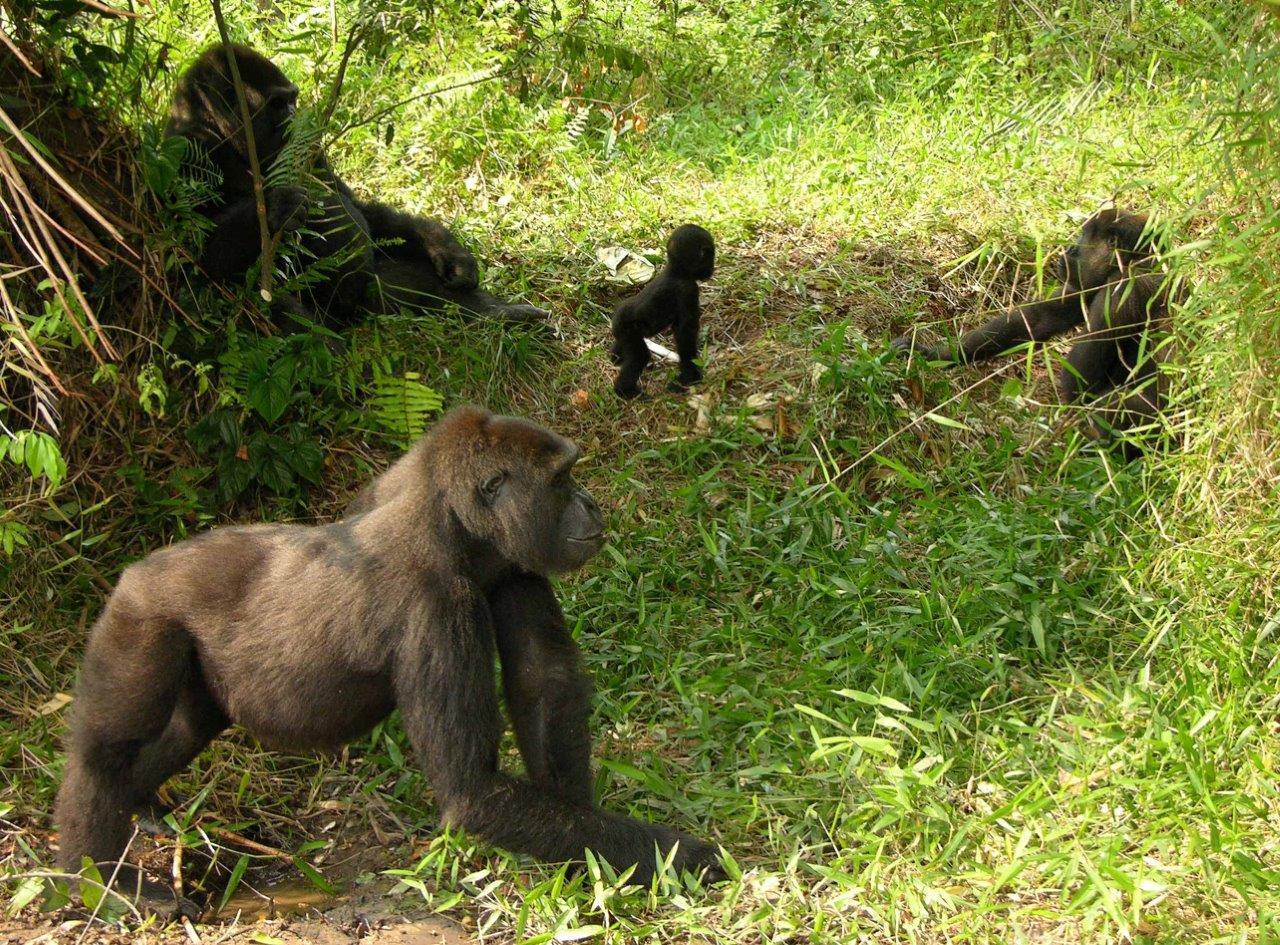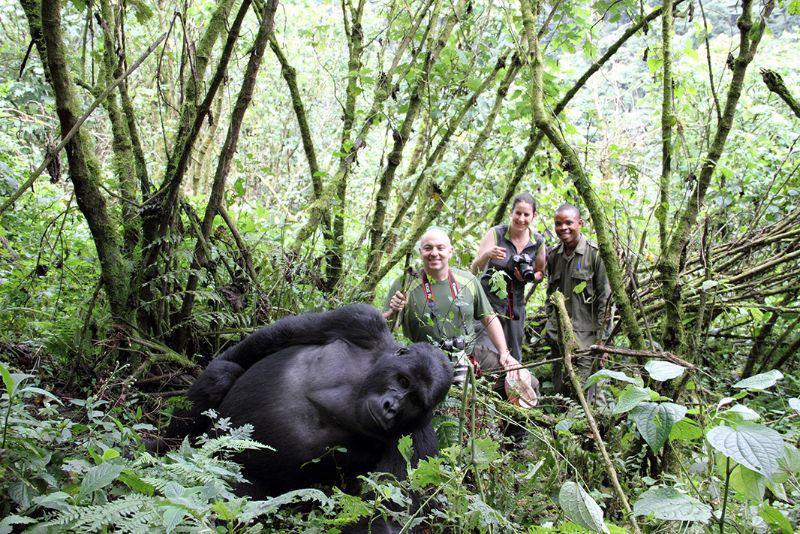The first image is the image on the left, the second image is the image on the right. Assess this claim about the two images: "In one image, one gorilla is walking leftward behind another and reaching an arm out to touch it.". Correct or not? Answer yes or no. No. The first image is the image on the left, the second image is the image on the right. Considering the images on both sides, is "There are two adult gurallies and two baby gurilles.  gorialles gore" valid? Answer yes or no. No. 